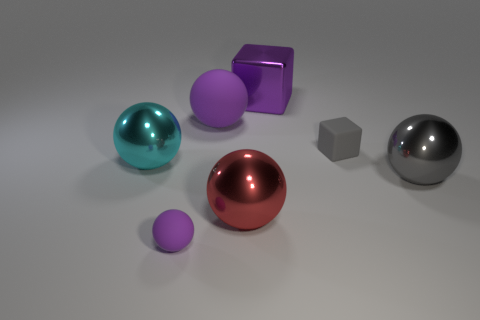Can you tell me about the textures of the objects? Certainly! The objects in the image have various textures: the spheres and the cube exhibit smooth surfaces with varying degrees of glossiness. In contrast, the uniquely shaped purple object, while still smooth, seems to have a slightly matte finish which diffuses the light differently from the more reflective surfaces. 